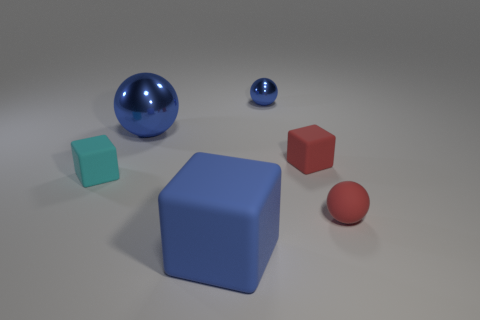Is there a blue metallic object of the same size as the blue block?
Provide a short and direct response. Yes. There is a tiny matte thing that is on the left side of the big blue metallic ball; is its shape the same as the tiny metallic object?
Provide a short and direct response. No. The small rubber ball has what color?
Offer a terse response. Red. What shape is the big object that is the same color as the big matte block?
Keep it short and to the point. Sphere. Is there a large blue rubber thing?
Give a very brief answer. Yes. The blue object that is made of the same material as the red ball is what size?
Make the answer very short. Large. What shape is the small object on the left side of the blue metallic object to the right of the blue sphere that is on the left side of the small metallic thing?
Provide a short and direct response. Cube. Is the number of small blue spheres that are to the left of the tiny blue sphere the same as the number of large matte cylinders?
Provide a succinct answer. Yes. What size is the matte cube that is the same color as the small rubber sphere?
Keep it short and to the point. Small. Does the big blue rubber thing have the same shape as the small cyan thing?
Your answer should be compact. Yes. 